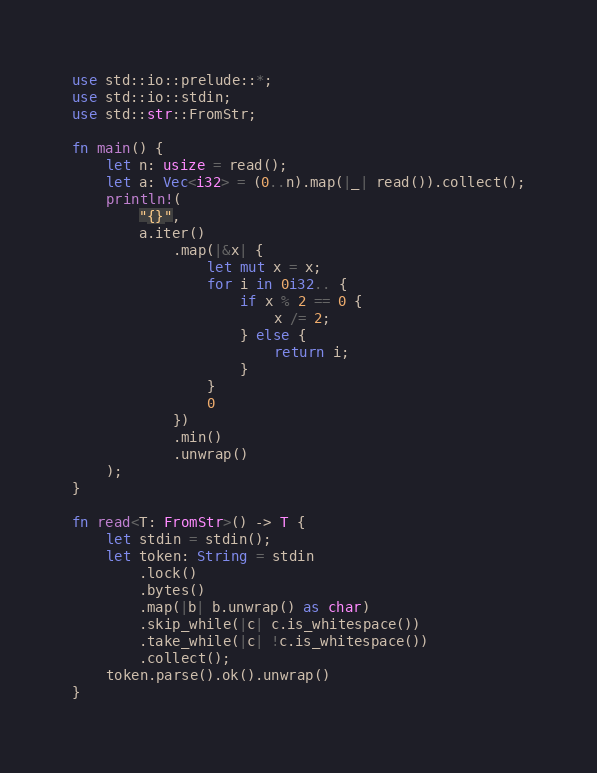Convert code to text. <code><loc_0><loc_0><loc_500><loc_500><_Rust_>use std::io::prelude::*;
use std::io::stdin;
use std::str::FromStr;

fn main() {
    let n: usize = read();
    let a: Vec<i32> = (0..n).map(|_| read()).collect();
    println!(
        "{}",
        a.iter()
            .map(|&x| {
                let mut x = x;
                for i in 0i32.. {
                    if x % 2 == 0 {
                        x /= 2;
                    } else {
                        return i;
                    }
                }
                0
            })
            .min()
            .unwrap()
    );
}

fn read<T: FromStr>() -> T {
    let stdin = stdin();
    let token: String = stdin
        .lock()
        .bytes()
        .map(|b| b.unwrap() as char)
        .skip_while(|c| c.is_whitespace())
        .take_while(|c| !c.is_whitespace())
        .collect();
    token.parse().ok().unwrap()
}
</code> 